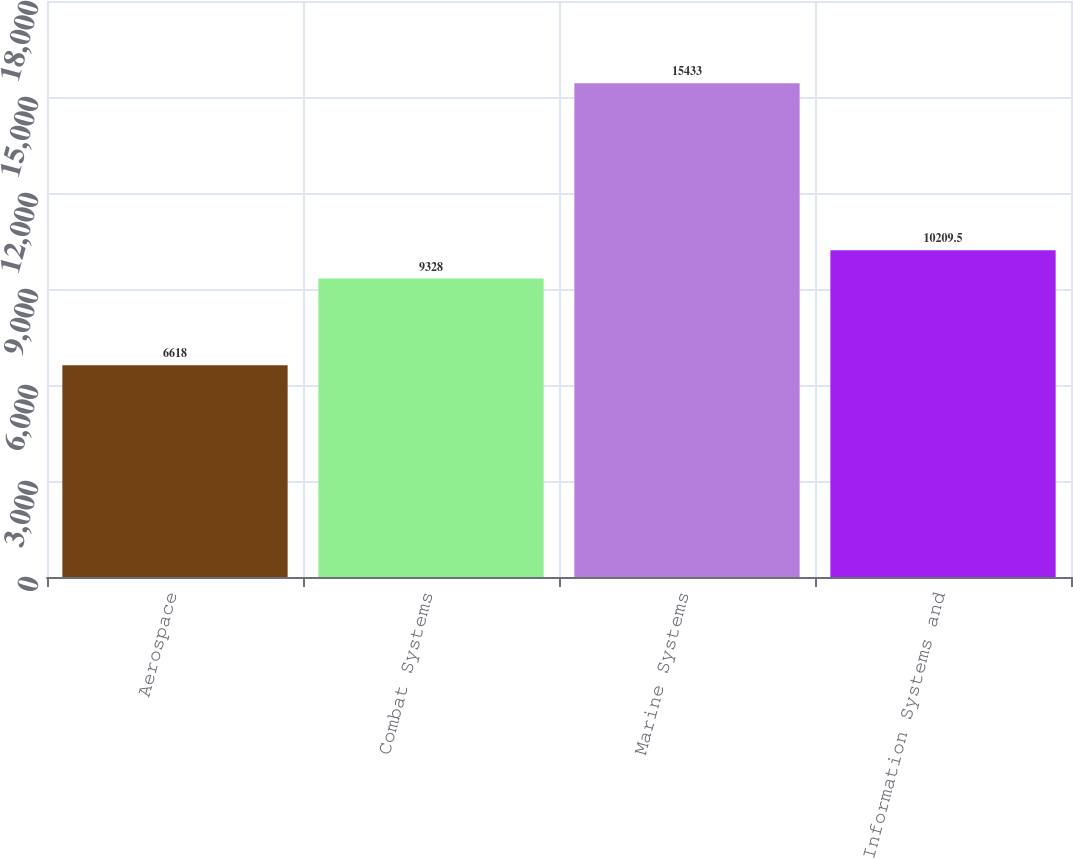<chart> <loc_0><loc_0><loc_500><loc_500><bar_chart><fcel>Aerospace<fcel>Combat Systems<fcel>Marine Systems<fcel>Information Systems and<nl><fcel>6618<fcel>9328<fcel>15433<fcel>10209.5<nl></chart> 